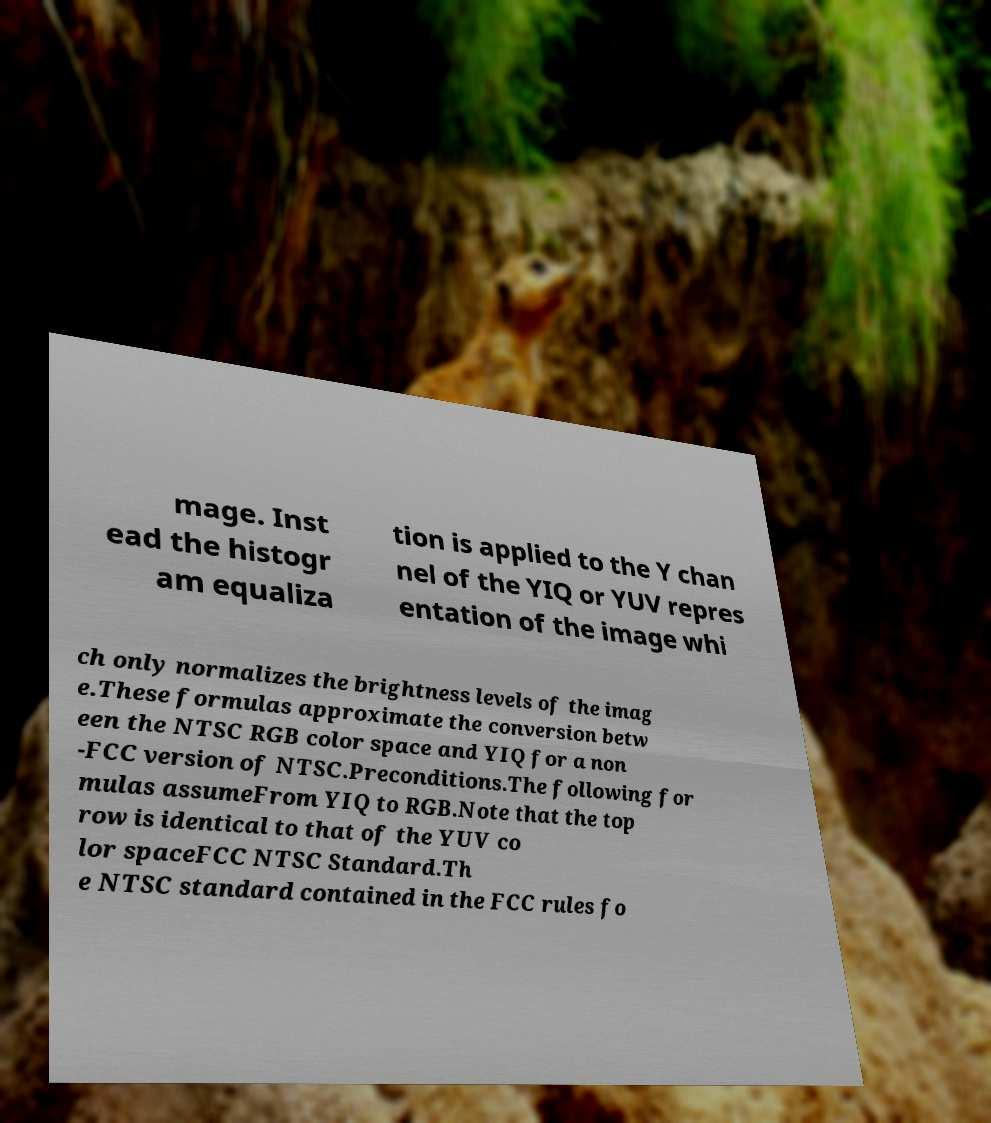Can you accurately transcribe the text from the provided image for me? mage. Inst ead the histogr am equaliza tion is applied to the Y chan nel of the YIQ or YUV repres entation of the image whi ch only normalizes the brightness levels of the imag e.These formulas approximate the conversion betw een the NTSC RGB color space and YIQ for a non -FCC version of NTSC.Preconditions.The following for mulas assumeFrom YIQ to RGB.Note that the top row is identical to that of the YUV co lor spaceFCC NTSC Standard.Th e NTSC standard contained in the FCC rules fo 